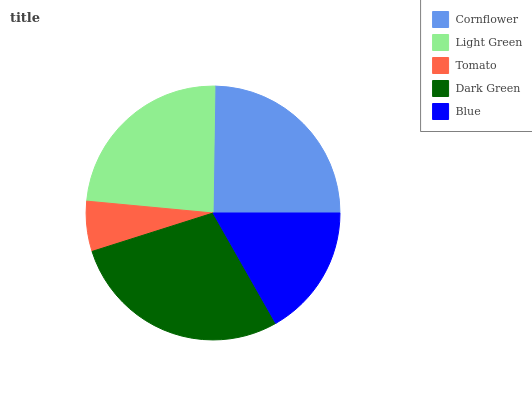Is Tomato the minimum?
Answer yes or no. Yes. Is Dark Green the maximum?
Answer yes or no. Yes. Is Light Green the minimum?
Answer yes or no. No. Is Light Green the maximum?
Answer yes or no. No. Is Cornflower greater than Light Green?
Answer yes or no. Yes. Is Light Green less than Cornflower?
Answer yes or no. Yes. Is Light Green greater than Cornflower?
Answer yes or no. No. Is Cornflower less than Light Green?
Answer yes or no. No. Is Light Green the high median?
Answer yes or no. Yes. Is Light Green the low median?
Answer yes or no. Yes. Is Cornflower the high median?
Answer yes or no. No. Is Tomato the low median?
Answer yes or no. No. 